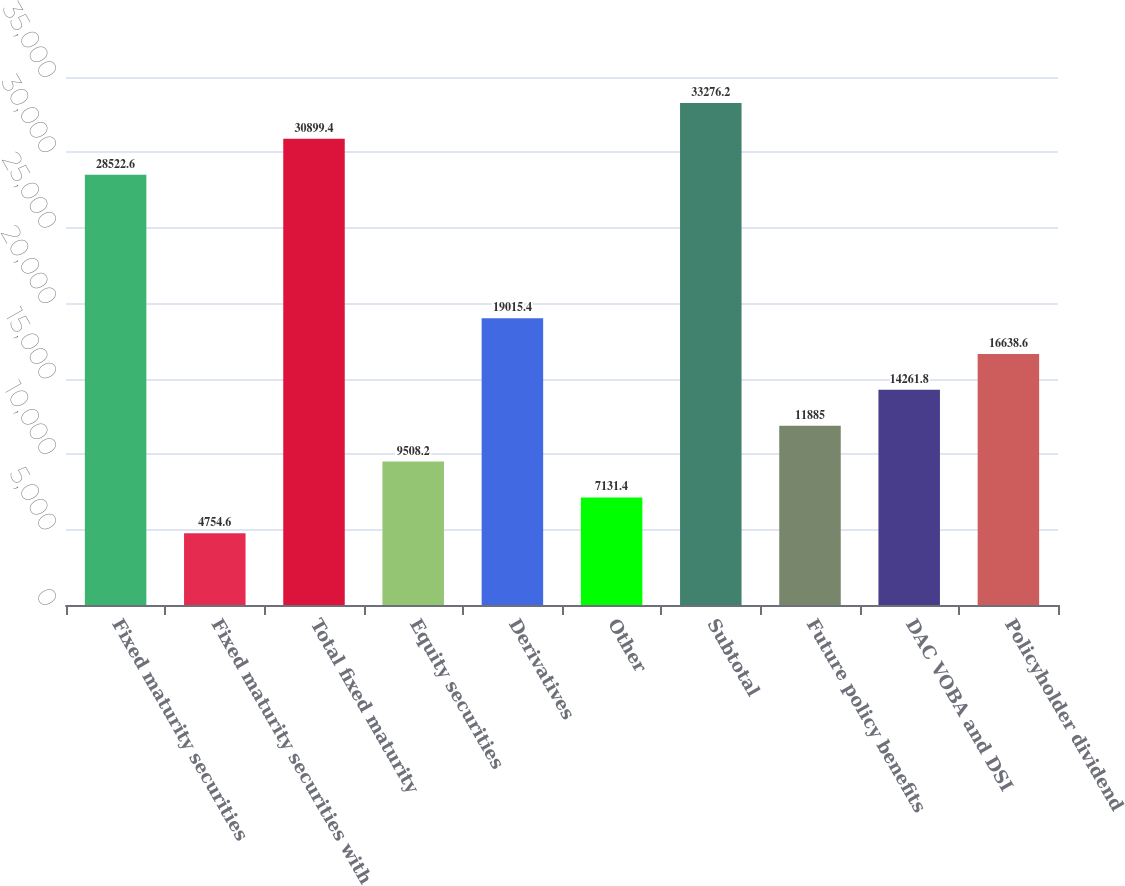<chart> <loc_0><loc_0><loc_500><loc_500><bar_chart><fcel>Fixed maturity securities<fcel>Fixed maturity securities with<fcel>Total fixed maturity<fcel>Equity securities<fcel>Derivatives<fcel>Other<fcel>Subtotal<fcel>Future policy benefits<fcel>DAC VOBA and DSI<fcel>Policyholder dividend<nl><fcel>28522.6<fcel>4754.6<fcel>30899.4<fcel>9508.2<fcel>19015.4<fcel>7131.4<fcel>33276.2<fcel>11885<fcel>14261.8<fcel>16638.6<nl></chart> 